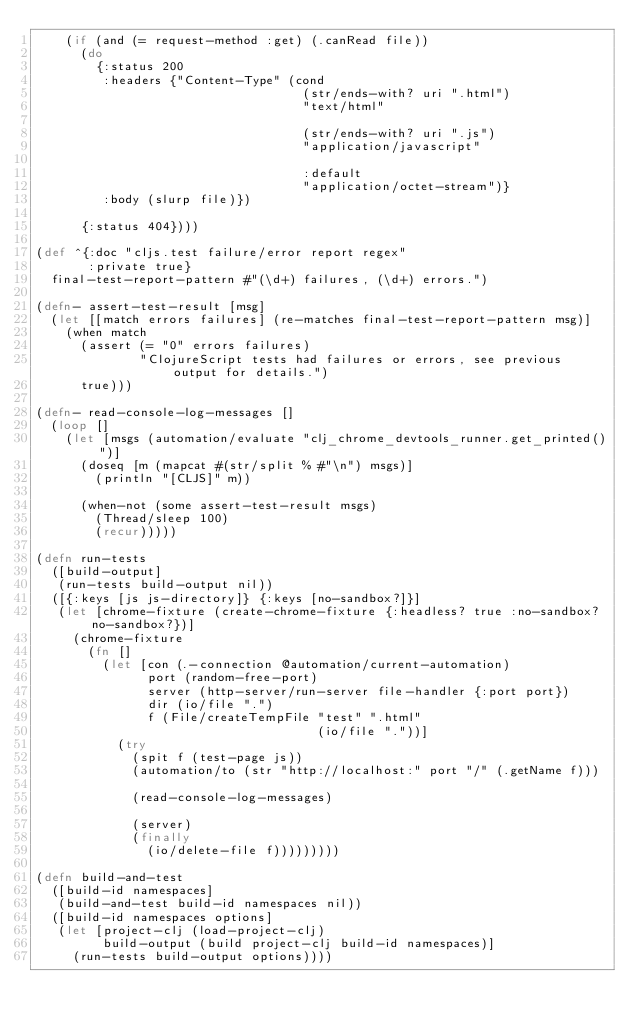<code> <loc_0><loc_0><loc_500><loc_500><_Clojure_>    (if (and (= request-method :get) (.canRead file))
      (do
        {:status 200
         :headers {"Content-Type" (cond
                                    (str/ends-with? uri ".html")
                                    "text/html"

                                    (str/ends-with? uri ".js")
                                    "application/javascript"

                                    :default
                                    "application/octet-stream")}
         :body (slurp file)})

      {:status 404})))

(def ^{:doc "cljs.test failure/error report regex"
       :private true}
  final-test-report-pattern #"(\d+) failures, (\d+) errors.")

(defn- assert-test-result [msg]
  (let [[match errors failures] (re-matches final-test-report-pattern msg)]
    (when match
      (assert (= "0" errors failures)
              "ClojureScript tests had failures or errors, see previous output for details.")
      true)))

(defn- read-console-log-messages []
  (loop []
    (let [msgs (automation/evaluate "clj_chrome_devtools_runner.get_printed()")]
      (doseq [m (mapcat #(str/split % #"\n") msgs)]
        (println "[CLJS]" m))

      (when-not (some assert-test-result msgs)
        (Thread/sleep 100)
        (recur)))))

(defn run-tests
  ([build-output]
   (run-tests build-output nil))
  ([{:keys [js js-directory]} {:keys [no-sandbox?]}]
   (let [chrome-fixture (create-chrome-fixture {:headless? true :no-sandbox? no-sandbox?})]
     (chrome-fixture
       (fn []
         (let [con (.-connection @automation/current-automation)
               port (random-free-port)
               server (http-server/run-server file-handler {:port port})
               dir (io/file ".")
               f (File/createTempFile "test" ".html"
                                      (io/file "."))]
           (try
             (spit f (test-page js))
             (automation/to (str "http://localhost:" port "/" (.getName f)))

             (read-console-log-messages)

             (server)
             (finally
               (io/delete-file f)))))))))

(defn build-and-test
  ([build-id namespaces]
   (build-and-test build-id namespaces nil))
  ([build-id namespaces options]
   (let [project-clj (load-project-clj)
         build-output (build project-clj build-id namespaces)]
     (run-tests build-output options))))
</code> 